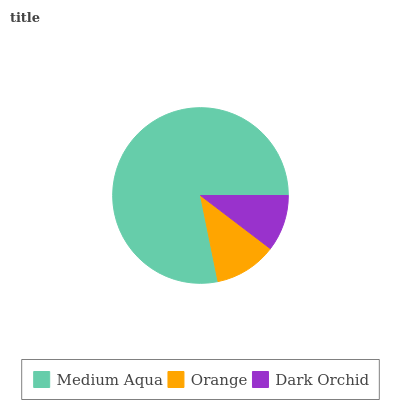Is Dark Orchid the minimum?
Answer yes or no. Yes. Is Medium Aqua the maximum?
Answer yes or no. Yes. Is Orange the minimum?
Answer yes or no. No. Is Orange the maximum?
Answer yes or no. No. Is Medium Aqua greater than Orange?
Answer yes or no. Yes. Is Orange less than Medium Aqua?
Answer yes or no. Yes. Is Orange greater than Medium Aqua?
Answer yes or no. No. Is Medium Aqua less than Orange?
Answer yes or no. No. Is Orange the high median?
Answer yes or no. Yes. Is Orange the low median?
Answer yes or no. Yes. Is Dark Orchid the high median?
Answer yes or no. No. Is Dark Orchid the low median?
Answer yes or no. No. 